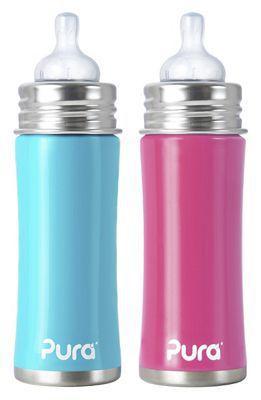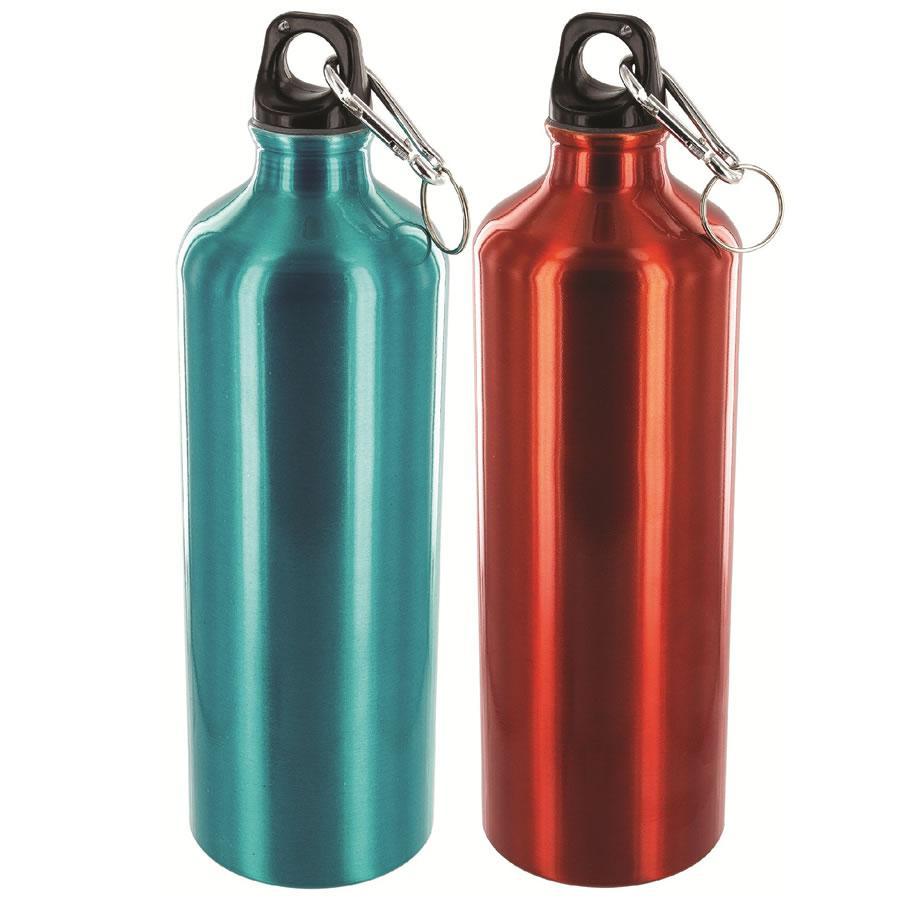The first image is the image on the left, the second image is the image on the right. Examine the images to the left and right. Is the description "There are seven bottles." accurate? Answer yes or no. No. 